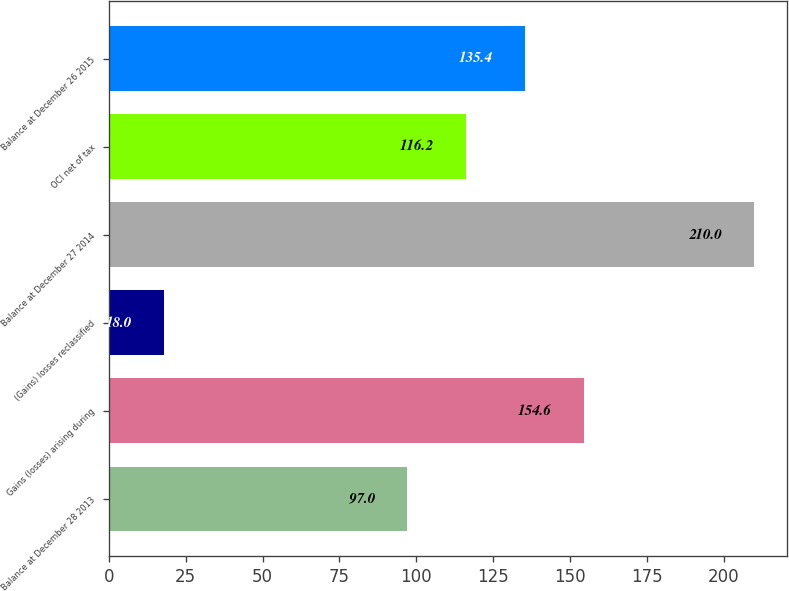<chart> <loc_0><loc_0><loc_500><loc_500><bar_chart><fcel>Balance at December 28 2013<fcel>Gains (losses) arising during<fcel>(Gains) losses reclassified<fcel>Balance at December 27 2014<fcel>OCI net of tax<fcel>Balance at December 26 2015<nl><fcel>97<fcel>154.6<fcel>18<fcel>210<fcel>116.2<fcel>135.4<nl></chart> 